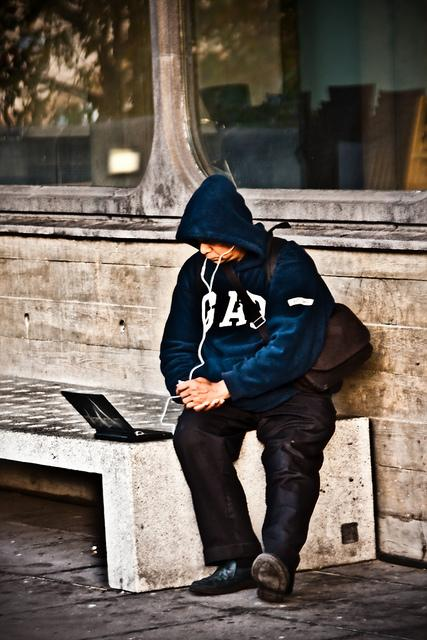What is the man sitting there doing? Please explain your reasoning. watching video. He has headphones in and is staring at the screen instead of typing on the keyboard. 